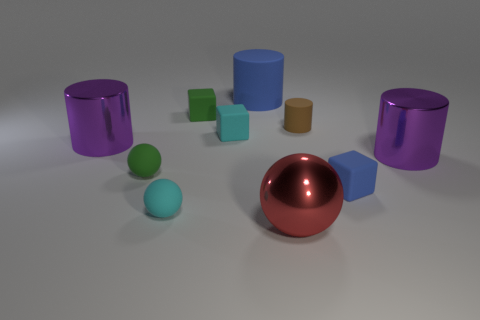There is a blue object in front of the blue rubber thing that is left of the brown cylinder; what shape is it?
Your answer should be very brief. Cube. What number of other objects are there of the same shape as the big blue rubber object?
Your response must be concise. 3. Are there any tiny blue matte things to the left of the brown matte cylinder?
Keep it short and to the point. No. The large sphere is what color?
Offer a very short reply. Red. Do the large matte cylinder and the small thing on the right side of the tiny brown rubber object have the same color?
Offer a terse response. Yes. Is there a green matte ball of the same size as the brown matte cylinder?
Keep it short and to the point. Yes. What size is the other object that is the same color as the large rubber object?
Make the answer very short. Small. What is the blue thing behind the tiny green ball made of?
Provide a short and direct response. Rubber. Is the number of tiny blue rubber blocks on the right side of the cyan rubber cube the same as the number of big blue rubber cylinders in front of the small cylinder?
Provide a short and direct response. No. Does the purple shiny object that is to the left of the small blue rubber block have the same size as the purple metallic object right of the big blue rubber cylinder?
Your response must be concise. Yes. 